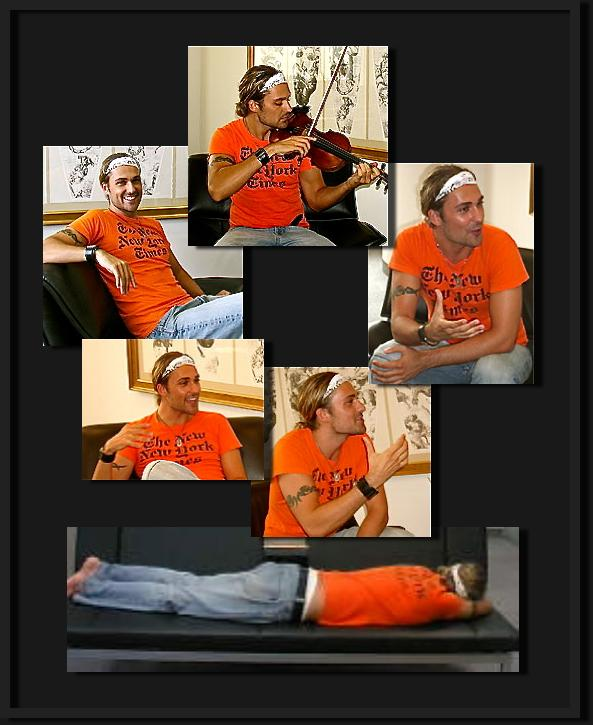Considering the man's attire, what type of event or activity could he possibly be attending or participating in? The man's vibrant orange t-shirt with black text aptly suggests he is attending a casual, likely interactive event. His attire, marked by comfort and visual appeal, along with his participation in activities like playing a violin and energetic expressions, indicates that he might be part of a recreational music class or a creative, informal gathering. The t-shirt's text might represent a community group or specific event, potentially a local music meetup or a casual workshop where attendees engage in learning and performing music while socializing. 